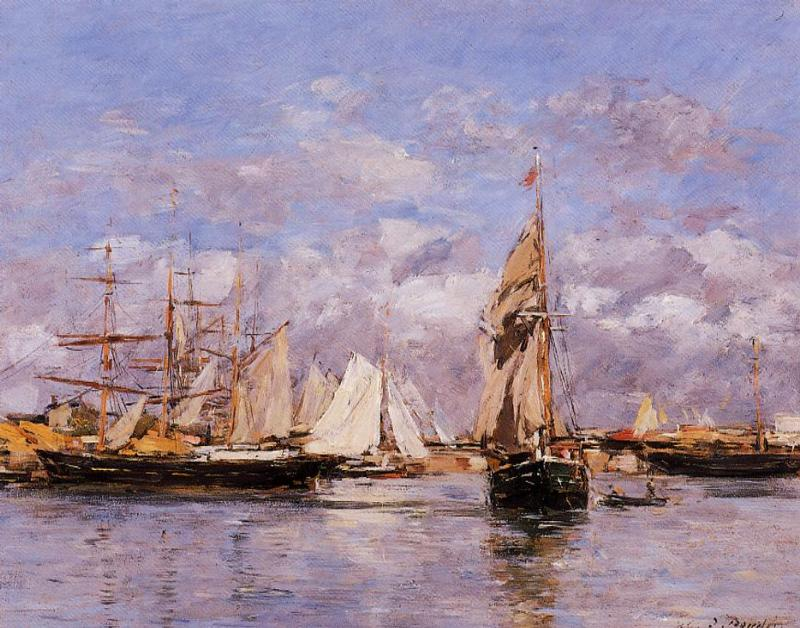Can you describe the mood of this scene and how the artist has conveyed it through their technique? The mood of the scene is serene and somewhat nostalgic. The artist has conveyed this through a harmonious color palette of soft blues, pinks, and yellows, and through loose, expressive brushstrokes that provide a sense of life and movement without detailing every aspect of the scene. The reflections on the water and the vibrant but not overly bright colors suggest a moment of calmness. Additionally, the clouds, while dynamic, do not appear threatening, adding to the painting's gentle ambiance. 